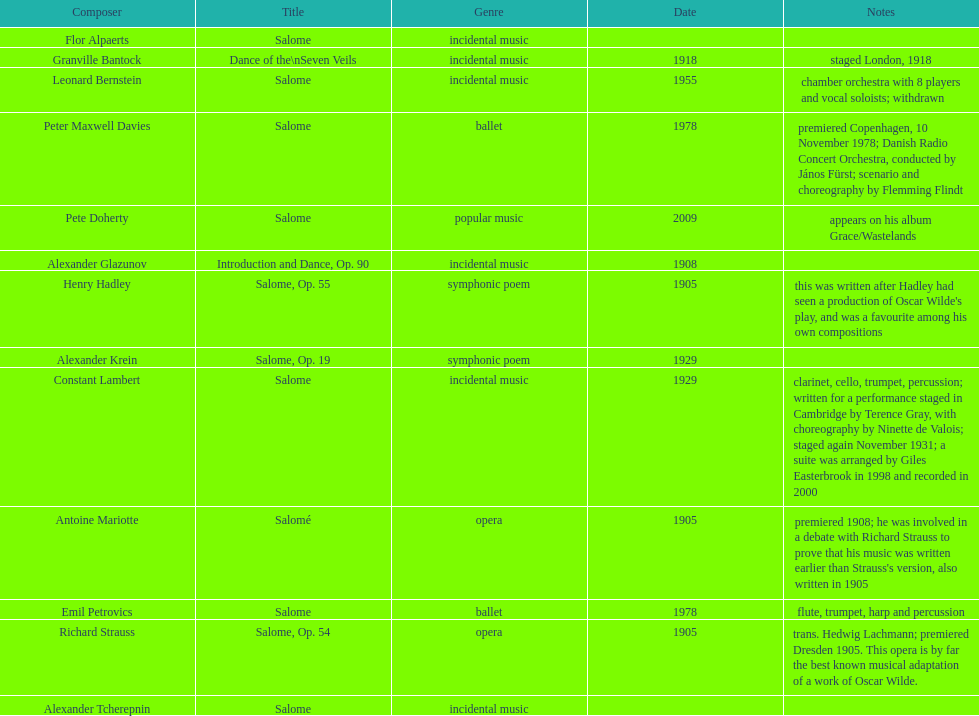How many pieces of work are titled "salome"? 11. 